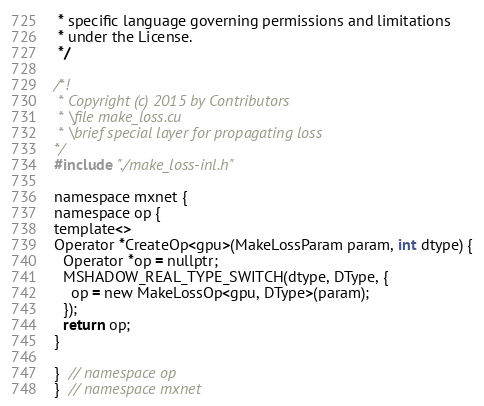<code> <loc_0><loc_0><loc_500><loc_500><_Cuda_> * specific language governing permissions and limitations
 * under the License.
 */

/*!
 * Copyright (c) 2015 by Contributors
 * \file make_loss.cu
 * \brief special layer for propagating loss
*/
#include "./make_loss-inl.h"

namespace mxnet {
namespace op {
template<>
Operator *CreateOp<gpu>(MakeLossParam param, int dtype) {
  Operator *op = nullptr;
  MSHADOW_REAL_TYPE_SWITCH(dtype, DType, {
    op = new MakeLossOp<gpu, DType>(param);
  });
  return op;
}

}  // namespace op
}  // namespace mxnet

</code> 